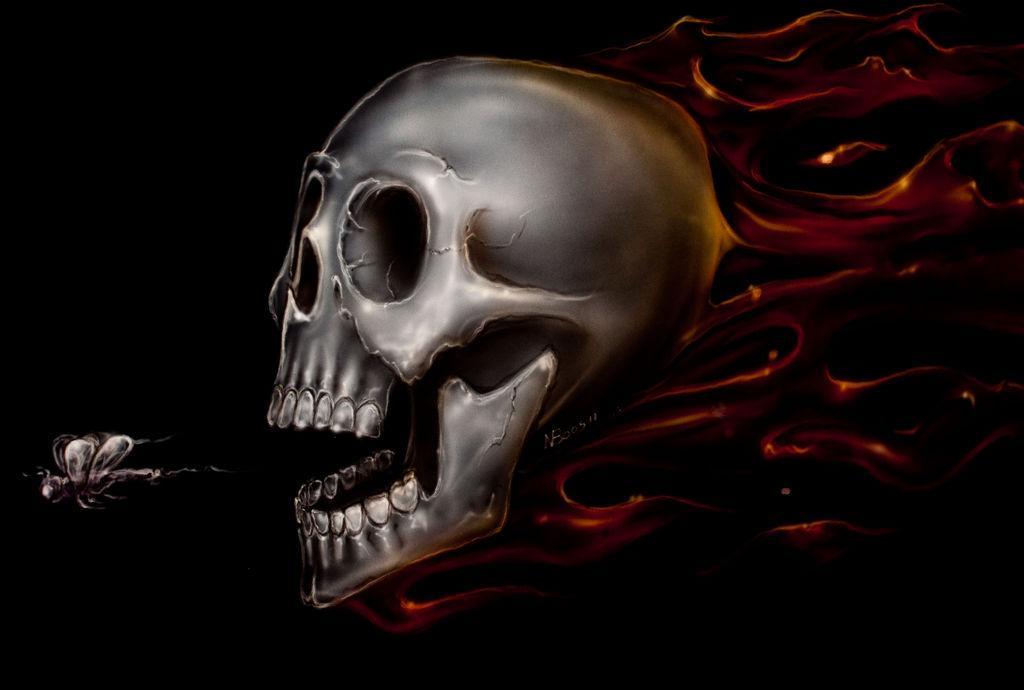Could you give a brief overview of what you see in this image? This is an animated image. Here we can see a skull and behind it there is a design and on the left there is an insect. 